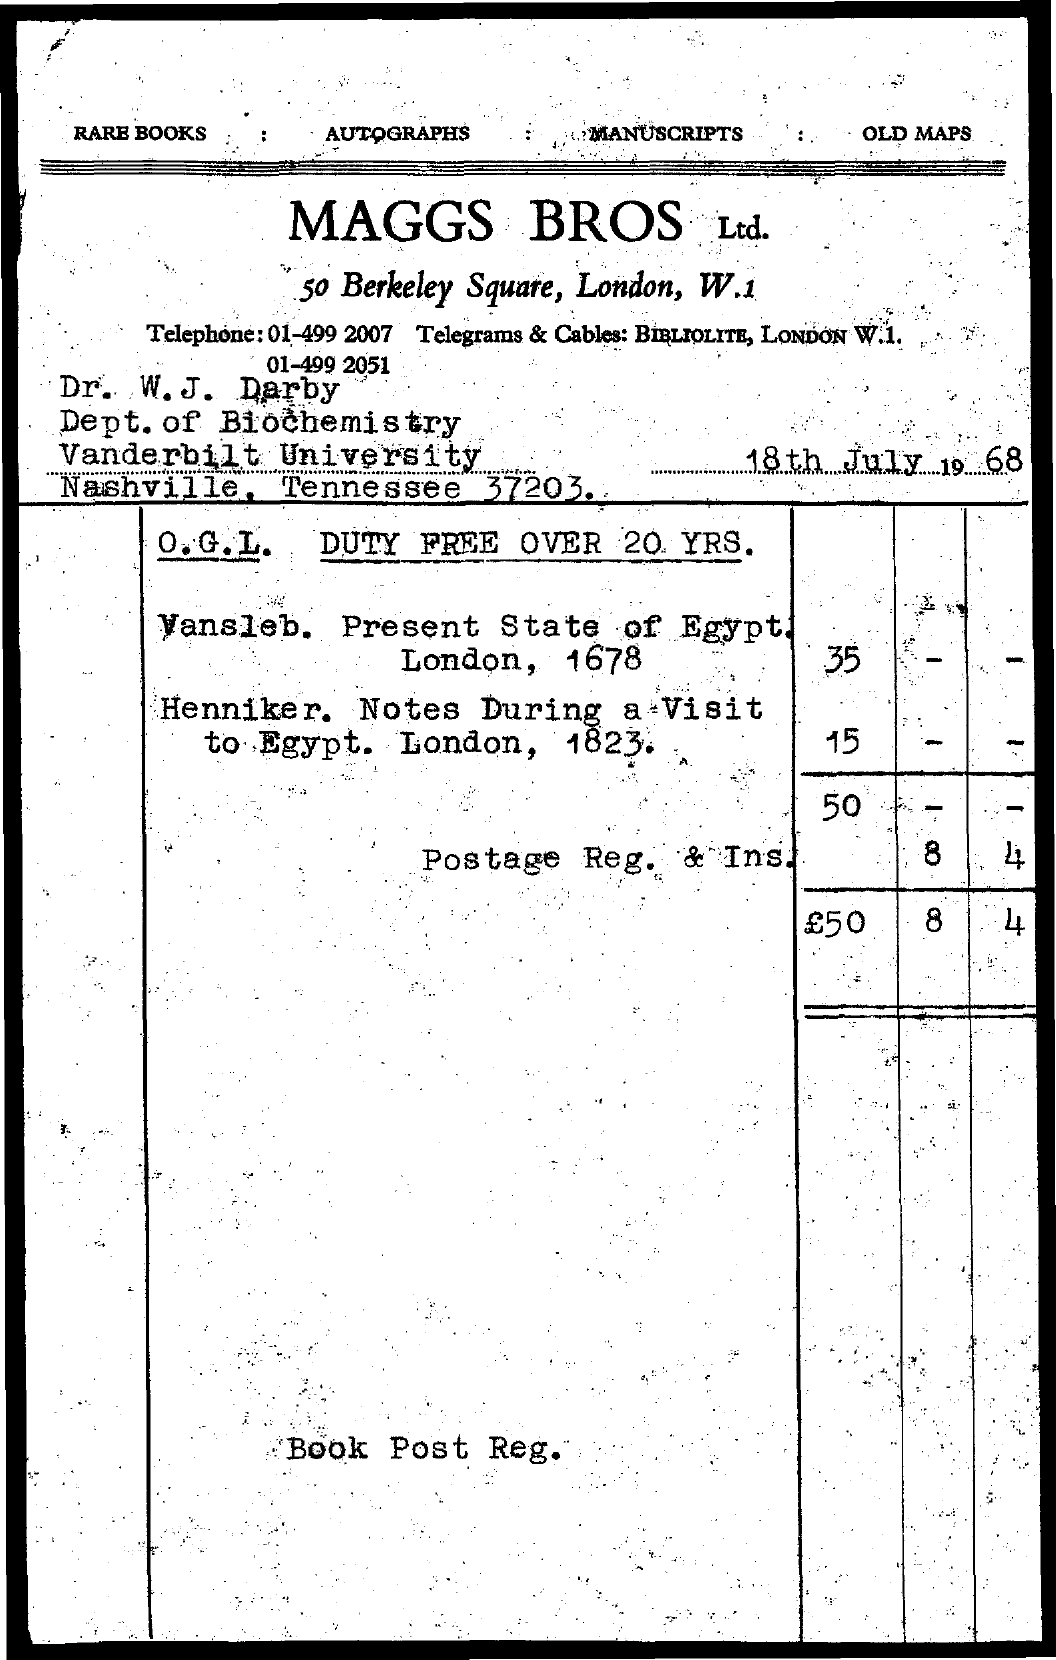What is the date mentioned in the document?
Your answer should be very brief. 18th July 1968. Which text is at the top-right?
Provide a short and direct response. Old maps. W.J Darby belongs to which university?
Provide a short and direct response. Vanderbilt University. W.J Darby belongs to which department?
Ensure brevity in your answer.  Dept. of Biochemistry. 